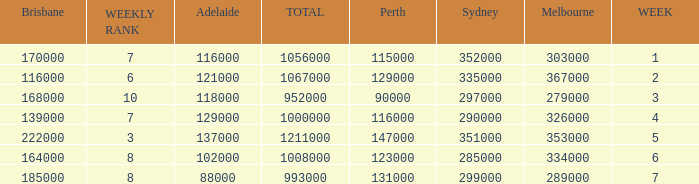How many Adelaide viewers were there in Week 5? 137000.0. Give me the full table as a dictionary. {'header': ['Brisbane', 'WEEKLY RANK', 'Adelaide', 'TOTAL', 'Perth', 'Sydney', 'Melbourne', 'WEEK'], 'rows': [['170000', '7', '116000', '1056000', '115000', '352000', '303000', '1'], ['116000', '6', '121000', '1067000', '129000', '335000', '367000', '2'], ['168000', '10', '118000', '952000', '90000', '297000', '279000', '3'], ['139000', '7', '129000', '1000000', '116000', '290000', '326000', '4'], ['222000', '3', '137000', '1211000', '147000', '351000', '353000', '5'], ['164000', '8', '102000', '1008000', '123000', '285000', '334000', '6'], ['185000', '8', '88000', '993000', '131000', '299000', '289000', '7']]} 